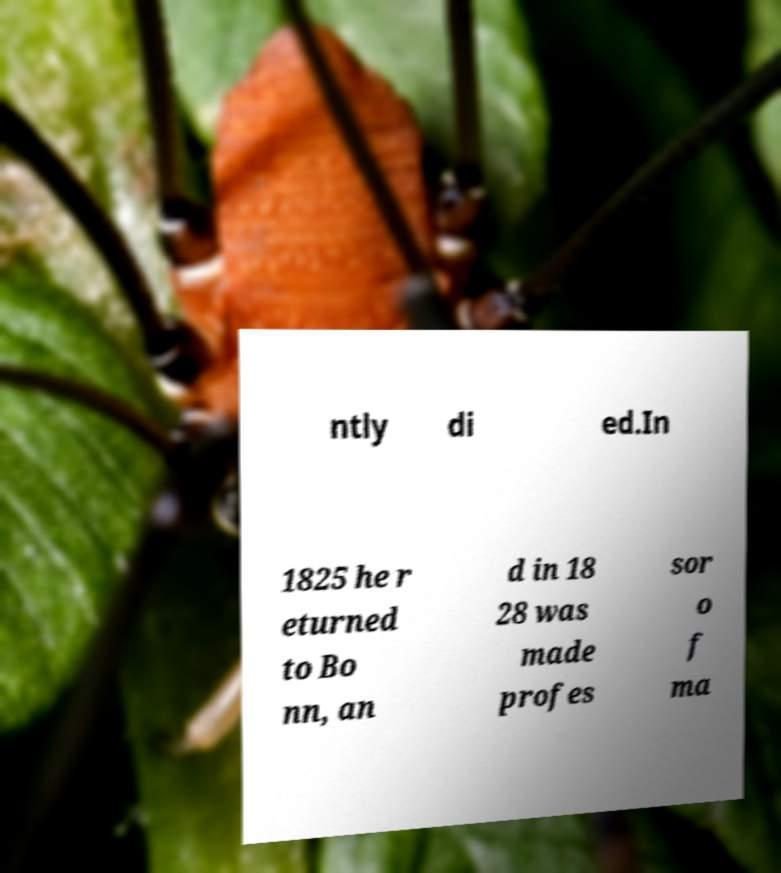Could you assist in decoding the text presented in this image and type it out clearly? ntly di ed.In 1825 he r eturned to Bo nn, an d in 18 28 was made profes sor o f ma 